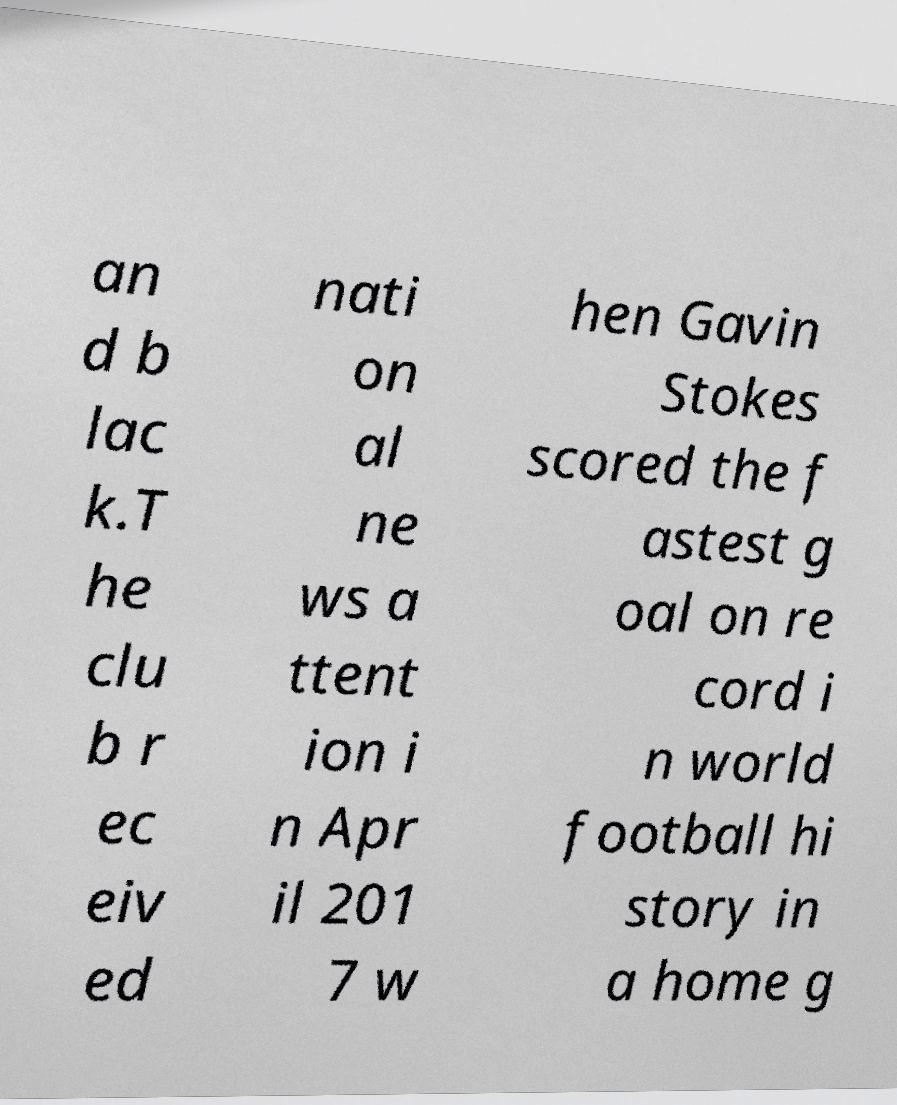Please identify and transcribe the text found in this image. an d b lac k.T he clu b r ec eiv ed nati on al ne ws a ttent ion i n Apr il 201 7 w hen Gavin Stokes scored the f astest g oal on re cord i n world football hi story in a home g 